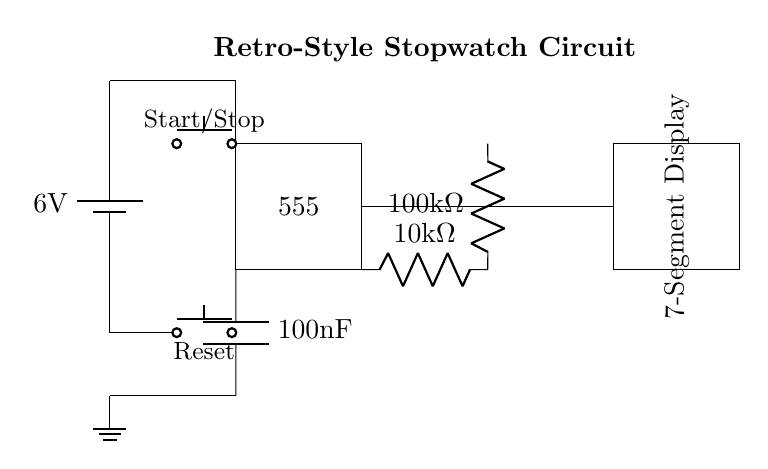What is the power supply voltage of this circuit? The circuit diagram shows a battery labeled with a voltage of 6 volts, indicating this is the power supply voltage for the circuit.
Answer: 6 volts What type of IC is used in this circuit? The diagram displays a rectangular box labeled "555," which identifies it as a 555 timer integrated circuit.
Answer: 555 timer What type of display is included in this circuit? There is a component labeled "7-Segment Display" in the circuit diagram, indicating that it is used for showing the output in a numerical format.
Answer: 7-Segment Display How many resistors are present in the circuit? By analyzing the circuit, there are two resistors labeled as 10k ohm and 100k ohm, which sums to a total of two resistors present in the circuit.
Answer: 2 How many buttons are included in this stopwatch circuit? The circuit diagram shows two push buttons labeled "Start/Stop" and "Reset," making the total number of buttons in the circuit equal to two.
Answer: 2 What is the capacitance value used for timing in this circuit? The circuit includes a capacitor labeled with a value of 100 nanofarads, which demonstrates the capacitance value relevant to the timing functions.
Answer: 100 nanofarads What is the purpose of the 555 timer in this circuit? The 555 timer is used in various timing applications; in this case, it functions as the timing mechanism for the stopwatch to measure elapsed time during sports events.
Answer: Timing mechanism 